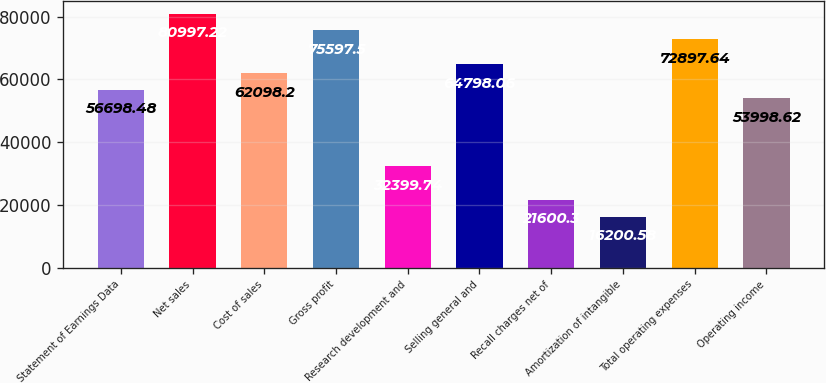Convert chart. <chart><loc_0><loc_0><loc_500><loc_500><bar_chart><fcel>Statement of Earnings Data<fcel>Net sales<fcel>Cost of sales<fcel>Gross profit<fcel>Research development and<fcel>Selling general and<fcel>Recall charges net of<fcel>Amortization of intangible<fcel>Total operating expenses<fcel>Operating income<nl><fcel>56698.5<fcel>80997.2<fcel>62098.2<fcel>75597.5<fcel>32399.7<fcel>64798.1<fcel>21600.3<fcel>16200.6<fcel>72897.6<fcel>53998.6<nl></chart> 